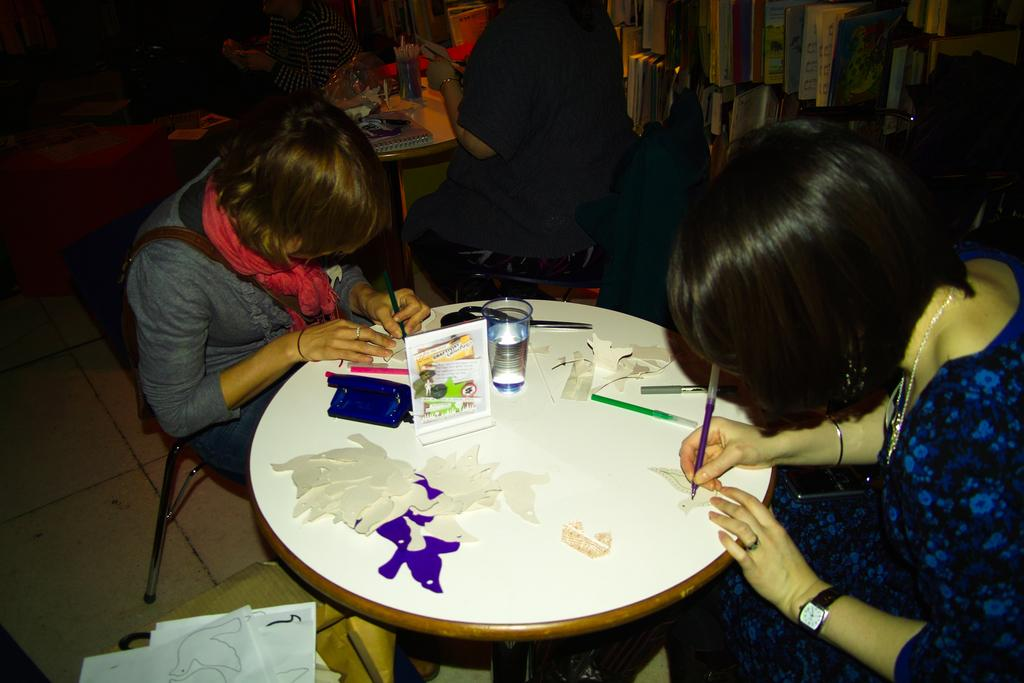What are the people in the image doing? The people in the image are sitting on chairs. What is on the floor in the image? Papers are on the floor in the image. What is on the table in the image? There is a glass, scissors, pens, colors, and a poster on the table in the image. How long does it take for the smoke to dissipate in the image? There is no smoke present in the image, so it is not possible to determine how long it would take for it to dissipate. 